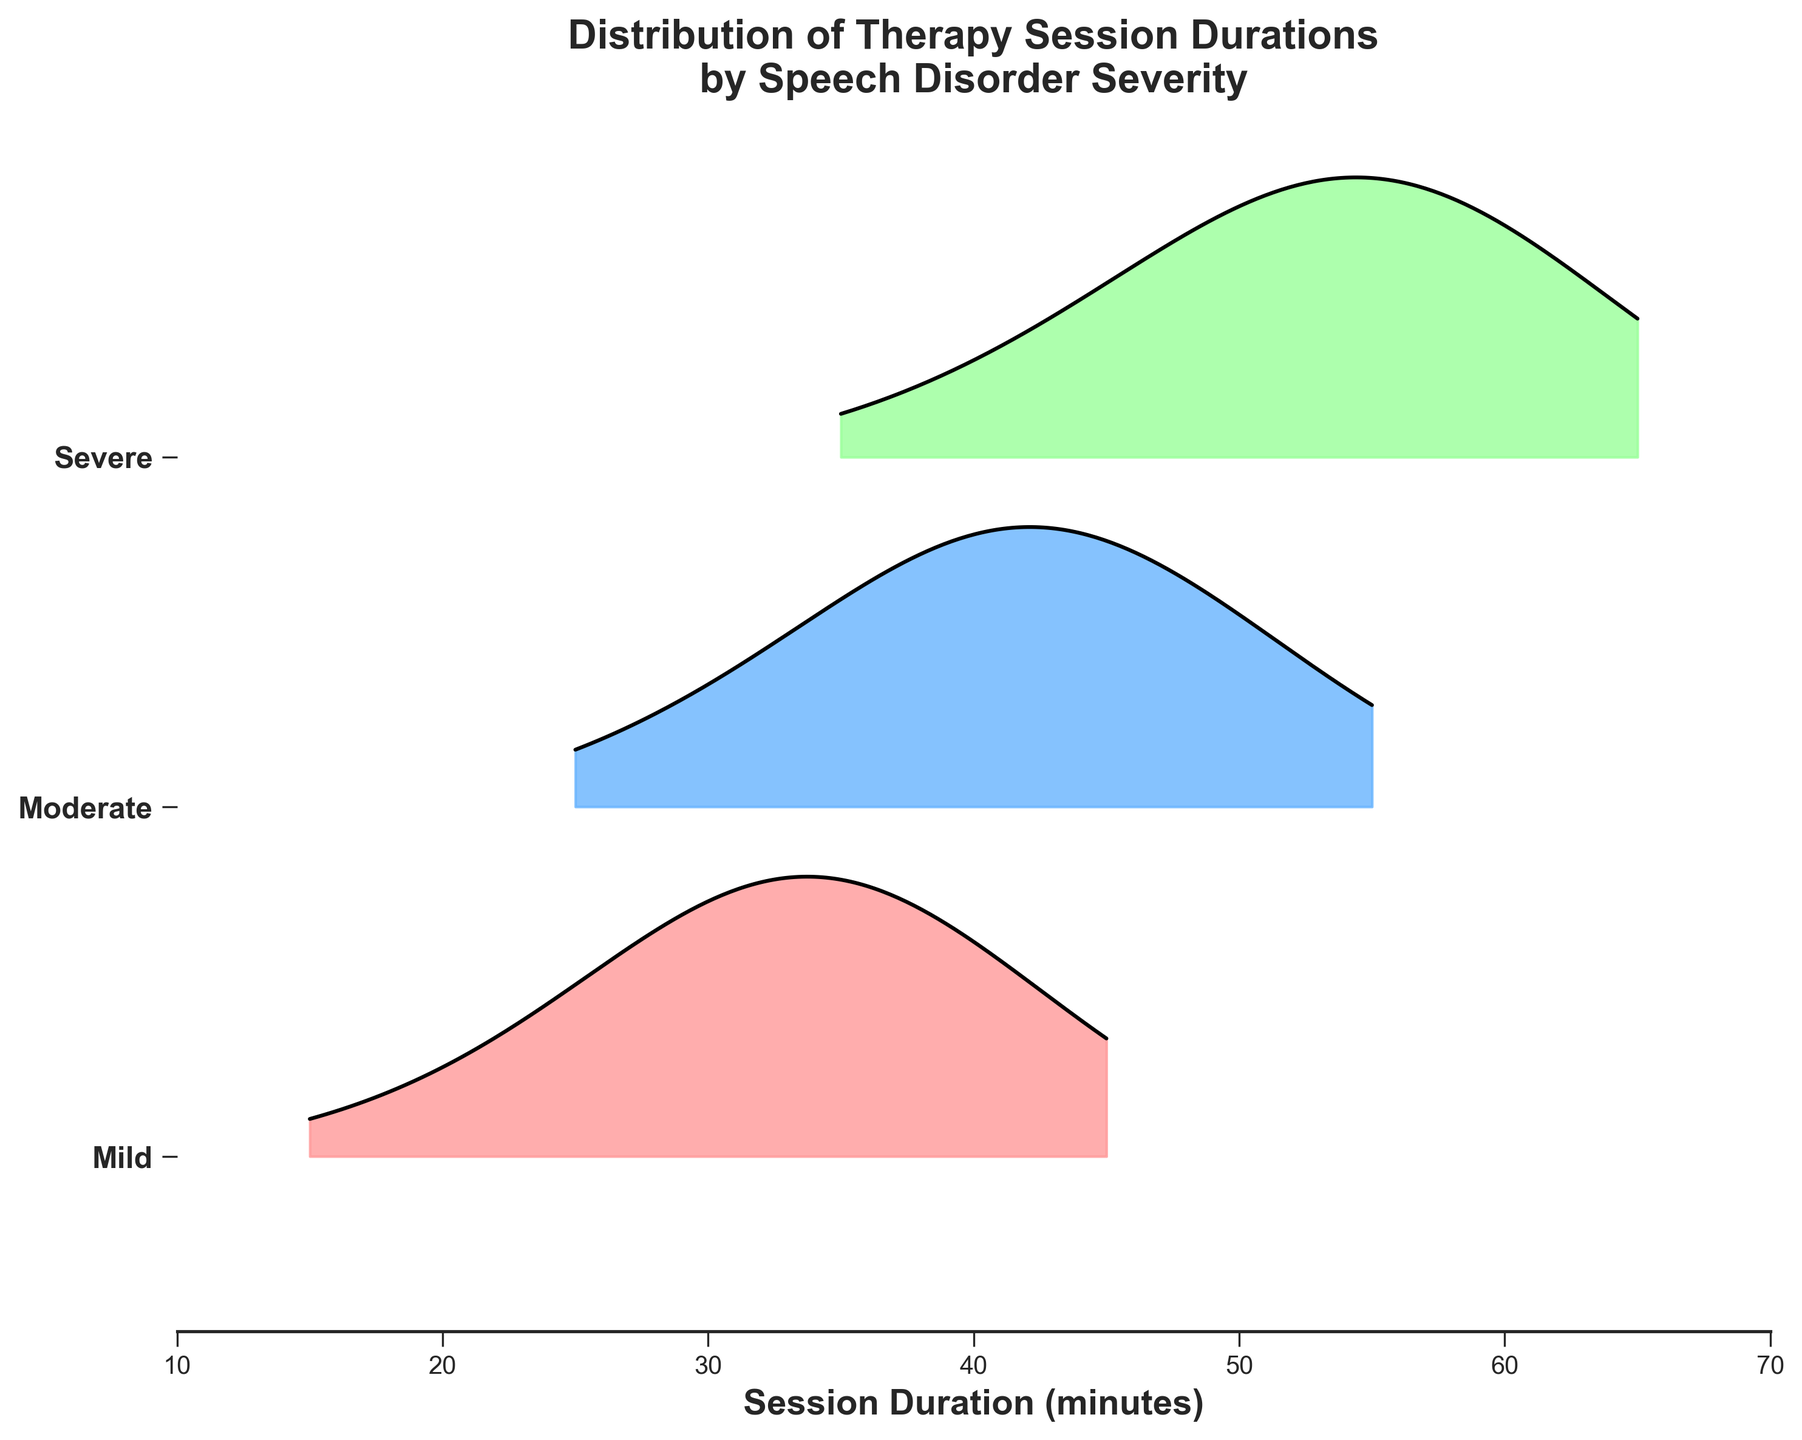How many severity levels are represented in the plot? The title of the plot indicates that it shows the distribution of therapy session durations by speech disorder severity. By observing the y-axis ticks and labels, we can see that there are three severity levels listed: Mild, Moderate, and Severe.
Answer: 3 What is the x-axis representing in this plot? The x-axis is labeled "Session Duration (minutes)," which indicates that it represents the duration of the therapy sessions in minutes for various severity levels of speech disorders.
Answer: Session Duration (minutes) Which severity level shows the widest range of therapy session durations? By comparing the x-axis range of the ridgelines for each severity level, "Severe" spans from around 35 to 65 minutes, which is the widest range compared to the other severity levels.
Answer: Severe For the "Mild" severity level, around which session duration is the highest frequency observed? Observing the ridgeline for the "Mild" severity level, the peak is centered around the 35 minutes mark, indicating the highest frequency of therapy sessions.
Answer: 35 minutes How does the peak frequency of the "Severe" severity level compare to that of the "Moderate" severity level? By comparing the peaks of the ridgelines, the "Severe" severity level's peak frequency occurs at around 55 minutes, which appears higher on the y-axis scale compared to the peak frequency of the "Moderate" severity level, which occurs at around 40 minutes.
Answer: Peak frequency at 55 minutes is higher than 40 minutes At what session duration do all three severity levels intersect the x-axis initially? All three ridgelines initially intersect the x-axis around the 30-minute mark. This is where each ridgeline starts.
Answer: 30 minutes What's the trend of therapy session durations as the severity level increases from Mild to Severe? Observing the ridgelines from "Mild" to "Severe," there is a clear trend of increasing session durations; "Mild" peaks around 35 minutes, "Moderate" peaks around 40 minutes, and "Severe" peaks at 55 minutes.
Answer: Increasing session duration Comparing "Mild" and "Moderate" severity levels, which one has a higher frequency at 40 minutes? By examining the ridgelines for "Mild" and "Moderate," the "Moderate" severity level shows higher frequency at the 40-minute mark compared to the "Mild" severity level.
Answer: Moderate What is the highest session duration shown for the "Severe" severity level? Looking at the "Severe" ridgeline, it extends and ends at approximately 65 minutes, indicating the highest session duration for this severity level.
Answer: 65 minutes 